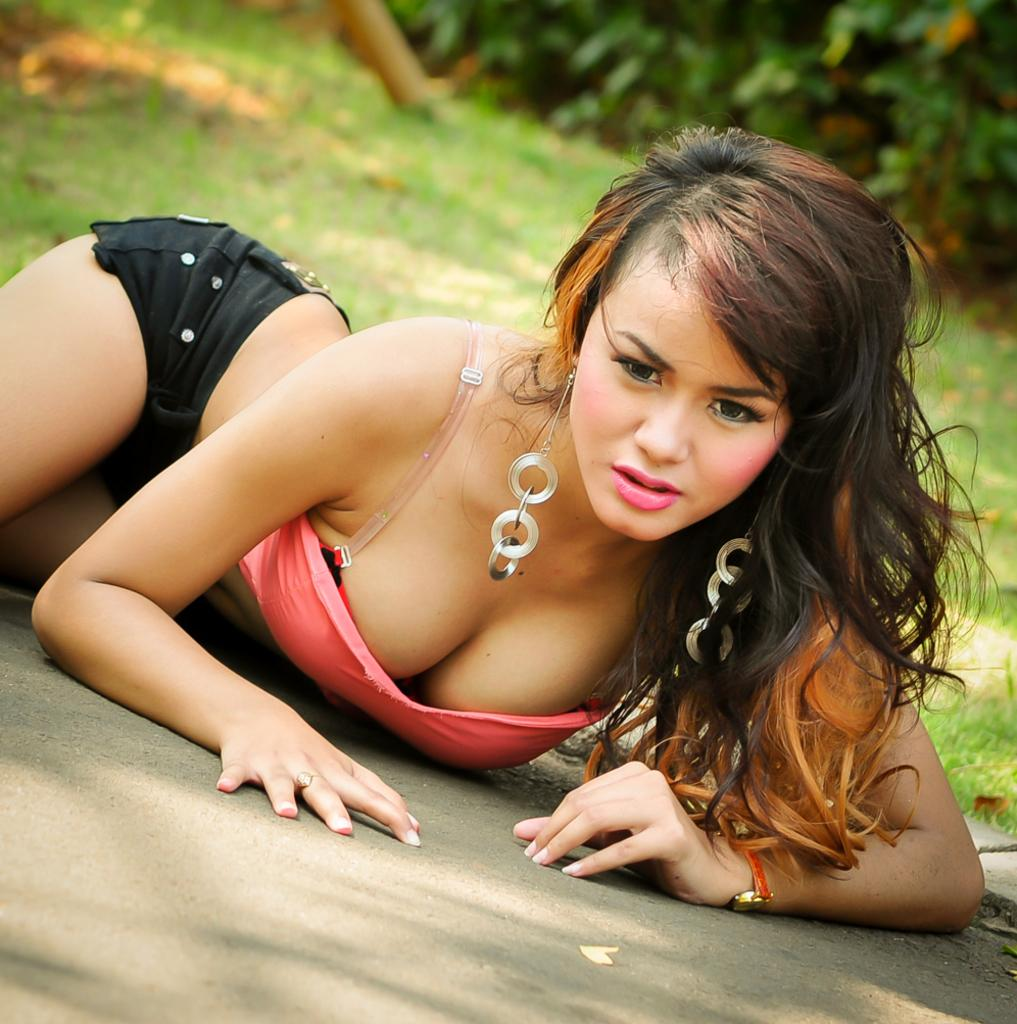Who is the main subject in the image? There is a girl in the image. What is the girl wearing? The girl is wearing a pink top. Where is the girl located in the image? The girl is lying on the roadside. What can be seen in the background of the image? There is a green lawn and plants visible in the background. What type of birth can be seen taking place in the image? There is no birth taking place in the image; it features a girl lying on the roadside. Can you point out the location of the map in the image? There is no map present in the image. 